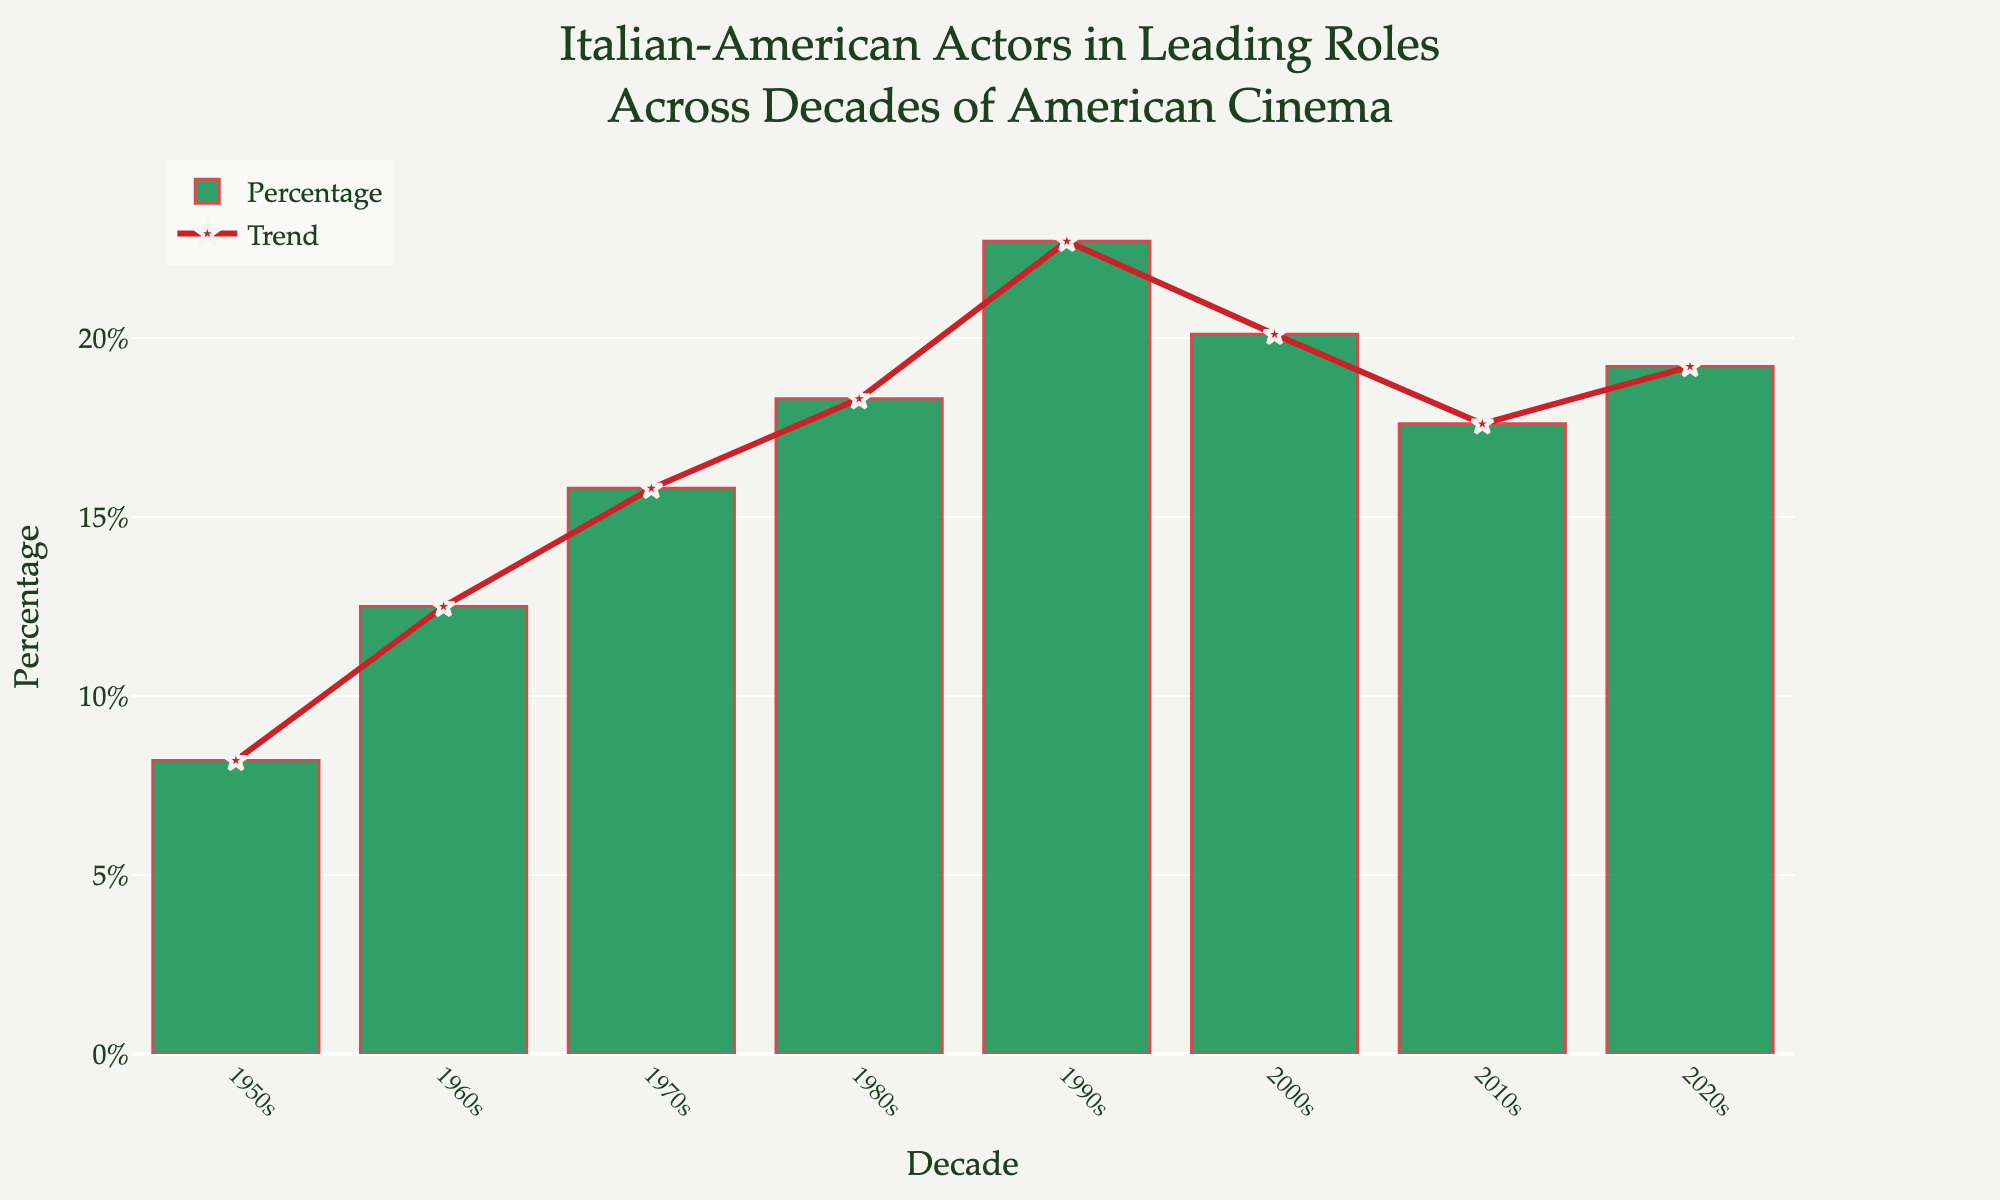What is the percentage of Italian-American actors in leading roles in the 1990s? Refer to the bar labeled '1990s' on the x-axis. The height of this bar represents the percentage, which is 22.7%.
Answer: 22.7% Which decade saw the least percentage of Italian-American actors in leading roles? The bar with the shortest height represents the decade with the least percentage. The 1950s bar has the shortest height, showing 8.2%.
Answer: 1950s Compare the percentage of Italian-American actors in leading roles between the 1980s and the 2010s. Which decade had a higher percentage? Look at the bars labeled '1980s' and '2010s' on the x-axis. The 1980s bar is higher than the 2010s bar, representing a higher percentage (18.3% vs. 17.6%).
Answer: 1980s What is the difference in the percentage of Italian-American actors in leading roles between the 2000s and the 2010s? Subtract the percentage in the 2010s from the percentage in the 2000s. The difference is 20.1% - 17.6% = 2.5%.
Answer: 2.5% How does the trendline's peak compare visually to the highest bar on the chart? The trendline's highest point (1990s) matches the highest bar on the chart, which is also the 1990s bar at 22.7%.
Answer: They match Which two consecutive decades saw the largest increase in the percentage of Italian-American actors in leading roles? Calculate the increase between each pair of consecutive decades and compare. The largest increase is between the 1980s (18.3%) and 1990s (22.7%), with an increase of 4.4%.
Answer: 1980s to 1990s In which decade did the percentage of Italian-American actors peak, and what was the value? The tallest bar on the chart represents the peak percentage. The highest bar is for the 1990s at 22.7%.
Answer: 1990s, 22.7% What visual elements are used to highlight the trend of Italian-American actors in leading roles over the decades? The bar chart represents the percentages with green bars, and a red trendline with star markers highlights the trend.
Answer: Green bars, red trendline with star markers What is the average percentage of Italian-American actors in leading roles over all the decades presented? Sum all the percentages and divide by the number of decades. (8.2 + 12.5 + 15.8 + 18.3 + 22.7 + 20.1 + 17.6 + 19.2) / 8 = 16.8%.
Answer: 16.8% 